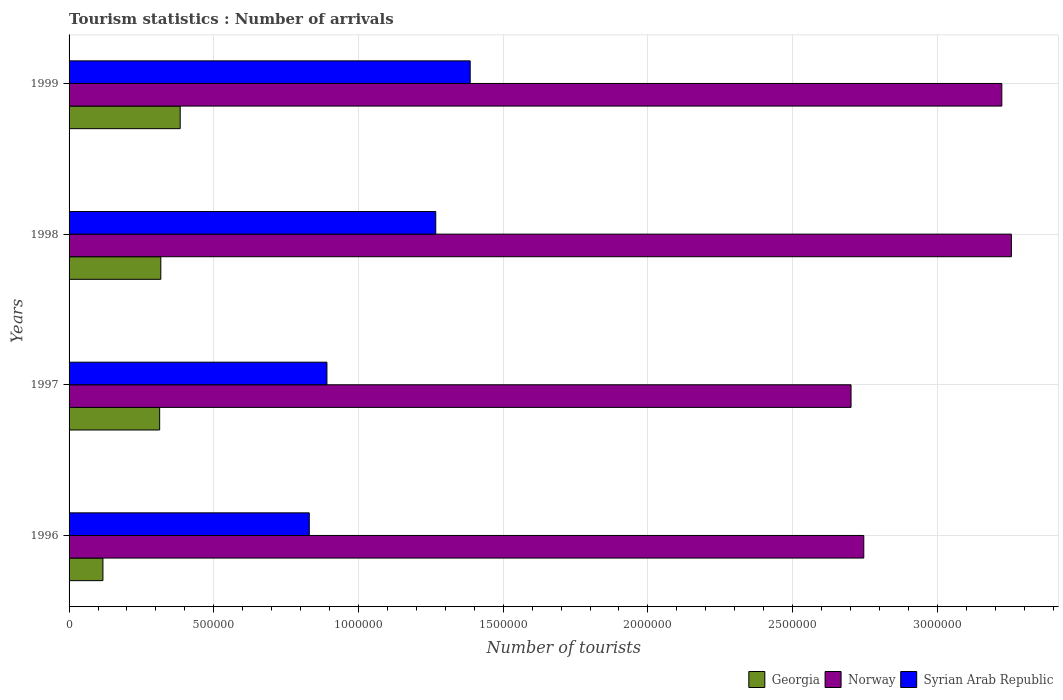How many groups of bars are there?
Ensure brevity in your answer.  4. Are the number of bars per tick equal to the number of legend labels?
Keep it short and to the point. Yes. How many bars are there on the 3rd tick from the top?
Provide a succinct answer. 3. How many bars are there on the 4th tick from the bottom?
Your answer should be compact. 3. What is the number of tourist arrivals in Syrian Arab Republic in 1996?
Provide a short and direct response. 8.30e+05. Across all years, what is the maximum number of tourist arrivals in Norway?
Your answer should be compact. 3.26e+06. Across all years, what is the minimum number of tourist arrivals in Norway?
Provide a short and direct response. 2.70e+06. What is the total number of tourist arrivals in Syrian Arab Republic in the graph?
Make the answer very short. 4.37e+06. What is the difference between the number of tourist arrivals in Syrian Arab Republic in 1998 and that in 1999?
Ensure brevity in your answer.  -1.19e+05. What is the difference between the number of tourist arrivals in Norway in 1997 and the number of tourist arrivals in Georgia in 1999?
Provide a succinct answer. 2.32e+06. What is the average number of tourist arrivals in Syrian Arab Republic per year?
Your answer should be compact. 1.09e+06. In the year 1999, what is the difference between the number of tourist arrivals in Syrian Arab Republic and number of tourist arrivals in Norway?
Offer a very short reply. -1.84e+06. In how many years, is the number of tourist arrivals in Georgia greater than 1900000 ?
Ensure brevity in your answer.  0. What is the ratio of the number of tourist arrivals in Norway in 1996 to that in 1997?
Your response must be concise. 1.02. What is the difference between the highest and the second highest number of tourist arrivals in Georgia?
Provide a succinct answer. 6.70e+04. What is the difference between the highest and the lowest number of tourist arrivals in Norway?
Ensure brevity in your answer.  5.54e+05. Is the sum of the number of tourist arrivals in Norway in 1996 and 1998 greater than the maximum number of tourist arrivals in Syrian Arab Republic across all years?
Offer a terse response. Yes. What does the 2nd bar from the top in 1996 represents?
Provide a succinct answer. Norway. What does the 2nd bar from the bottom in 1999 represents?
Give a very brief answer. Norway. How many years are there in the graph?
Give a very brief answer. 4. What is the difference between two consecutive major ticks on the X-axis?
Make the answer very short. 5.00e+05. Are the values on the major ticks of X-axis written in scientific E-notation?
Make the answer very short. No. Does the graph contain any zero values?
Your response must be concise. No. Does the graph contain grids?
Offer a very short reply. Yes. How many legend labels are there?
Provide a short and direct response. 3. How are the legend labels stacked?
Provide a short and direct response. Horizontal. What is the title of the graph?
Provide a short and direct response. Tourism statistics : Number of arrivals. What is the label or title of the X-axis?
Your answer should be compact. Number of tourists. What is the label or title of the Y-axis?
Offer a very short reply. Years. What is the Number of tourists in Georgia in 1996?
Ensure brevity in your answer.  1.17e+05. What is the Number of tourists in Norway in 1996?
Offer a very short reply. 2.75e+06. What is the Number of tourists of Syrian Arab Republic in 1996?
Your answer should be compact. 8.30e+05. What is the Number of tourists of Georgia in 1997?
Provide a short and direct response. 3.13e+05. What is the Number of tourists of Norway in 1997?
Provide a succinct answer. 2.70e+06. What is the Number of tourists in Syrian Arab Republic in 1997?
Your answer should be very brief. 8.91e+05. What is the Number of tourists in Georgia in 1998?
Your answer should be compact. 3.17e+05. What is the Number of tourists of Norway in 1998?
Your response must be concise. 3.26e+06. What is the Number of tourists of Syrian Arab Republic in 1998?
Give a very brief answer. 1.27e+06. What is the Number of tourists in Georgia in 1999?
Ensure brevity in your answer.  3.84e+05. What is the Number of tourists of Norway in 1999?
Ensure brevity in your answer.  3.22e+06. What is the Number of tourists in Syrian Arab Republic in 1999?
Your answer should be compact. 1.39e+06. Across all years, what is the maximum Number of tourists in Georgia?
Offer a terse response. 3.84e+05. Across all years, what is the maximum Number of tourists of Norway?
Ensure brevity in your answer.  3.26e+06. Across all years, what is the maximum Number of tourists in Syrian Arab Republic?
Your answer should be very brief. 1.39e+06. Across all years, what is the minimum Number of tourists of Georgia?
Provide a succinct answer. 1.17e+05. Across all years, what is the minimum Number of tourists of Norway?
Your answer should be compact. 2.70e+06. Across all years, what is the minimum Number of tourists of Syrian Arab Republic?
Offer a terse response. 8.30e+05. What is the total Number of tourists in Georgia in the graph?
Your response must be concise. 1.13e+06. What is the total Number of tourists of Norway in the graph?
Provide a succinct answer. 1.19e+07. What is the total Number of tourists of Syrian Arab Republic in the graph?
Your answer should be very brief. 4.37e+06. What is the difference between the Number of tourists in Georgia in 1996 and that in 1997?
Ensure brevity in your answer.  -1.96e+05. What is the difference between the Number of tourists of Norway in 1996 and that in 1997?
Make the answer very short. 4.40e+04. What is the difference between the Number of tourists in Syrian Arab Republic in 1996 and that in 1997?
Your answer should be compact. -6.10e+04. What is the difference between the Number of tourists of Georgia in 1996 and that in 1998?
Your answer should be compact. -2.00e+05. What is the difference between the Number of tourists of Norway in 1996 and that in 1998?
Ensure brevity in your answer.  -5.10e+05. What is the difference between the Number of tourists of Syrian Arab Republic in 1996 and that in 1998?
Your answer should be very brief. -4.37e+05. What is the difference between the Number of tourists in Georgia in 1996 and that in 1999?
Provide a succinct answer. -2.67e+05. What is the difference between the Number of tourists in Norway in 1996 and that in 1999?
Keep it short and to the point. -4.77e+05. What is the difference between the Number of tourists in Syrian Arab Republic in 1996 and that in 1999?
Provide a succinct answer. -5.56e+05. What is the difference between the Number of tourists of Georgia in 1997 and that in 1998?
Make the answer very short. -4000. What is the difference between the Number of tourists in Norway in 1997 and that in 1998?
Offer a terse response. -5.54e+05. What is the difference between the Number of tourists in Syrian Arab Republic in 1997 and that in 1998?
Your response must be concise. -3.76e+05. What is the difference between the Number of tourists in Georgia in 1997 and that in 1999?
Give a very brief answer. -7.10e+04. What is the difference between the Number of tourists in Norway in 1997 and that in 1999?
Offer a terse response. -5.21e+05. What is the difference between the Number of tourists of Syrian Arab Republic in 1997 and that in 1999?
Offer a very short reply. -4.95e+05. What is the difference between the Number of tourists in Georgia in 1998 and that in 1999?
Offer a very short reply. -6.70e+04. What is the difference between the Number of tourists of Norway in 1998 and that in 1999?
Give a very brief answer. 3.30e+04. What is the difference between the Number of tourists in Syrian Arab Republic in 1998 and that in 1999?
Your response must be concise. -1.19e+05. What is the difference between the Number of tourists of Georgia in 1996 and the Number of tourists of Norway in 1997?
Offer a terse response. -2.58e+06. What is the difference between the Number of tourists in Georgia in 1996 and the Number of tourists in Syrian Arab Republic in 1997?
Give a very brief answer. -7.74e+05. What is the difference between the Number of tourists of Norway in 1996 and the Number of tourists of Syrian Arab Republic in 1997?
Keep it short and to the point. 1.86e+06. What is the difference between the Number of tourists in Georgia in 1996 and the Number of tourists in Norway in 1998?
Your answer should be very brief. -3.14e+06. What is the difference between the Number of tourists of Georgia in 1996 and the Number of tourists of Syrian Arab Republic in 1998?
Offer a terse response. -1.15e+06. What is the difference between the Number of tourists of Norway in 1996 and the Number of tourists of Syrian Arab Republic in 1998?
Provide a succinct answer. 1.48e+06. What is the difference between the Number of tourists in Georgia in 1996 and the Number of tourists in Norway in 1999?
Your answer should be compact. -3.11e+06. What is the difference between the Number of tourists in Georgia in 1996 and the Number of tourists in Syrian Arab Republic in 1999?
Keep it short and to the point. -1.27e+06. What is the difference between the Number of tourists of Norway in 1996 and the Number of tourists of Syrian Arab Republic in 1999?
Your answer should be compact. 1.36e+06. What is the difference between the Number of tourists of Georgia in 1997 and the Number of tourists of Norway in 1998?
Give a very brief answer. -2.94e+06. What is the difference between the Number of tourists of Georgia in 1997 and the Number of tourists of Syrian Arab Republic in 1998?
Your answer should be compact. -9.54e+05. What is the difference between the Number of tourists in Norway in 1997 and the Number of tourists in Syrian Arab Republic in 1998?
Offer a very short reply. 1.44e+06. What is the difference between the Number of tourists in Georgia in 1997 and the Number of tourists in Norway in 1999?
Give a very brief answer. -2.91e+06. What is the difference between the Number of tourists in Georgia in 1997 and the Number of tourists in Syrian Arab Republic in 1999?
Provide a succinct answer. -1.07e+06. What is the difference between the Number of tourists in Norway in 1997 and the Number of tourists in Syrian Arab Republic in 1999?
Provide a short and direct response. 1.32e+06. What is the difference between the Number of tourists in Georgia in 1998 and the Number of tourists in Norway in 1999?
Your response must be concise. -2.91e+06. What is the difference between the Number of tourists of Georgia in 1998 and the Number of tourists of Syrian Arab Republic in 1999?
Provide a short and direct response. -1.07e+06. What is the difference between the Number of tourists of Norway in 1998 and the Number of tourists of Syrian Arab Republic in 1999?
Keep it short and to the point. 1.87e+06. What is the average Number of tourists of Georgia per year?
Your answer should be very brief. 2.83e+05. What is the average Number of tourists of Norway per year?
Ensure brevity in your answer.  2.98e+06. What is the average Number of tourists of Syrian Arab Republic per year?
Make the answer very short. 1.09e+06. In the year 1996, what is the difference between the Number of tourists of Georgia and Number of tourists of Norway?
Keep it short and to the point. -2.63e+06. In the year 1996, what is the difference between the Number of tourists in Georgia and Number of tourists in Syrian Arab Republic?
Give a very brief answer. -7.13e+05. In the year 1996, what is the difference between the Number of tourists of Norway and Number of tourists of Syrian Arab Republic?
Your answer should be very brief. 1.92e+06. In the year 1997, what is the difference between the Number of tourists in Georgia and Number of tourists in Norway?
Your answer should be very brief. -2.39e+06. In the year 1997, what is the difference between the Number of tourists of Georgia and Number of tourists of Syrian Arab Republic?
Your answer should be compact. -5.78e+05. In the year 1997, what is the difference between the Number of tourists in Norway and Number of tourists in Syrian Arab Republic?
Provide a succinct answer. 1.81e+06. In the year 1998, what is the difference between the Number of tourists of Georgia and Number of tourists of Norway?
Provide a short and direct response. -2.94e+06. In the year 1998, what is the difference between the Number of tourists in Georgia and Number of tourists in Syrian Arab Republic?
Your response must be concise. -9.50e+05. In the year 1998, what is the difference between the Number of tourists in Norway and Number of tourists in Syrian Arab Republic?
Give a very brief answer. 1.99e+06. In the year 1999, what is the difference between the Number of tourists of Georgia and Number of tourists of Norway?
Your response must be concise. -2.84e+06. In the year 1999, what is the difference between the Number of tourists in Georgia and Number of tourists in Syrian Arab Republic?
Provide a succinct answer. -1.00e+06. In the year 1999, what is the difference between the Number of tourists in Norway and Number of tourists in Syrian Arab Republic?
Ensure brevity in your answer.  1.84e+06. What is the ratio of the Number of tourists in Georgia in 1996 to that in 1997?
Provide a succinct answer. 0.37. What is the ratio of the Number of tourists of Norway in 1996 to that in 1997?
Your answer should be compact. 1.02. What is the ratio of the Number of tourists of Syrian Arab Republic in 1996 to that in 1997?
Make the answer very short. 0.93. What is the ratio of the Number of tourists in Georgia in 1996 to that in 1998?
Your answer should be compact. 0.37. What is the ratio of the Number of tourists of Norway in 1996 to that in 1998?
Give a very brief answer. 0.84. What is the ratio of the Number of tourists of Syrian Arab Republic in 1996 to that in 1998?
Keep it short and to the point. 0.66. What is the ratio of the Number of tourists of Georgia in 1996 to that in 1999?
Offer a terse response. 0.3. What is the ratio of the Number of tourists of Norway in 1996 to that in 1999?
Make the answer very short. 0.85. What is the ratio of the Number of tourists in Syrian Arab Republic in 1996 to that in 1999?
Your answer should be compact. 0.6. What is the ratio of the Number of tourists in Georgia in 1997 to that in 1998?
Give a very brief answer. 0.99. What is the ratio of the Number of tourists in Norway in 1997 to that in 1998?
Offer a very short reply. 0.83. What is the ratio of the Number of tourists of Syrian Arab Republic in 1997 to that in 1998?
Offer a terse response. 0.7. What is the ratio of the Number of tourists of Georgia in 1997 to that in 1999?
Your answer should be very brief. 0.82. What is the ratio of the Number of tourists in Norway in 1997 to that in 1999?
Keep it short and to the point. 0.84. What is the ratio of the Number of tourists in Syrian Arab Republic in 1997 to that in 1999?
Provide a short and direct response. 0.64. What is the ratio of the Number of tourists of Georgia in 1998 to that in 1999?
Offer a terse response. 0.83. What is the ratio of the Number of tourists in Norway in 1998 to that in 1999?
Provide a succinct answer. 1.01. What is the ratio of the Number of tourists in Syrian Arab Republic in 1998 to that in 1999?
Your answer should be very brief. 0.91. What is the difference between the highest and the second highest Number of tourists in Georgia?
Provide a succinct answer. 6.70e+04. What is the difference between the highest and the second highest Number of tourists in Norway?
Your answer should be compact. 3.30e+04. What is the difference between the highest and the second highest Number of tourists of Syrian Arab Republic?
Make the answer very short. 1.19e+05. What is the difference between the highest and the lowest Number of tourists of Georgia?
Keep it short and to the point. 2.67e+05. What is the difference between the highest and the lowest Number of tourists in Norway?
Your answer should be compact. 5.54e+05. What is the difference between the highest and the lowest Number of tourists in Syrian Arab Republic?
Your response must be concise. 5.56e+05. 